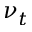<formula> <loc_0><loc_0><loc_500><loc_500>\nu _ { t }</formula> 